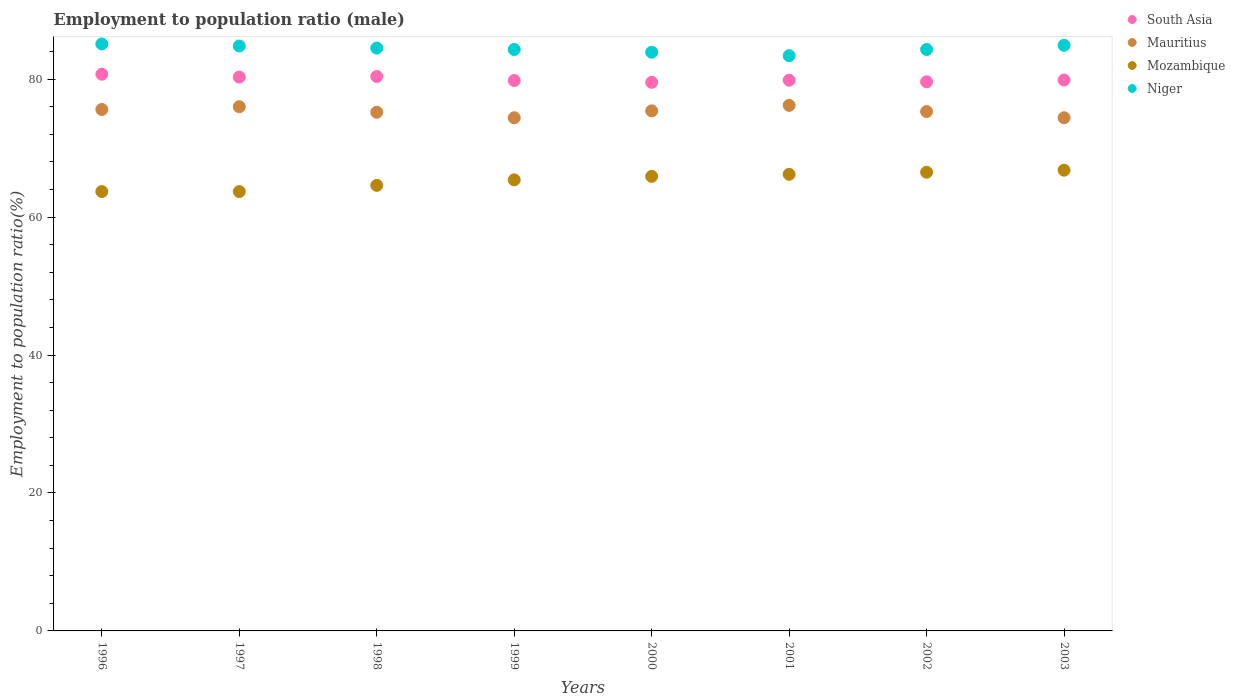Is the number of dotlines equal to the number of legend labels?
Offer a very short reply. Yes. What is the employment to population ratio in Niger in 2000?
Provide a short and direct response. 83.9. Across all years, what is the maximum employment to population ratio in Niger?
Ensure brevity in your answer.  85.1. Across all years, what is the minimum employment to population ratio in South Asia?
Keep it short and to the point. 79.53. In which year was the employment to population ratio in Niger maximum?
Your response must be concise. 1996. What is the total employment to population ratio in Mauritius in the graph?
Keep it short and to the point. 602.5. What is the difference between the employment to population ratio in Niger in 1997 and that in 2000?
Your answer should be very brief. 0.9. What is the difference between the employment to population ratio in Niger in 2002 and the employment to population ratio in South Asia in 1997?
Provide a short and direct response. 4. What is the average employment to population ratio in South Asia per year?
Offer a terse response. 80.01. In the year 2003, what is the difference between the employment to population ratio in South Asia and employment to population ratio in Mauritius?
Give a very brief answer. 5.47. In how many years, is the employment to population ratio in Mozambique greater than 4 %?
Provide a short and direct response. 8. What is the ratio of the employment to population ratio in Mauritius in 1998 to that in 2000?
Provide a short and direct response. 1. Is the employment to population ratio in Mozambique in 2000 less than that in 2002?
Provide a succinct answer. Yes. What is the difference between the highest and the second highest employment to population ratio in Mozambique?
Make the answer very short. 0.3. What is the difference between the highest and the lowest employment to population ratio in Mauritius?
Give a very brief answer. 1.8. In how many years, is the employment to population ratio in Mauritius greater than the average employment to population ratio in Mauritius taken over all years?
Give a very brief answer. 4. Is it the case that in every year, the sum of the employment to population ratio in Mozambique and employment to population ratio in Mauritius  is greater than the sum of employment to population ratio in Niger and employment to population ratio in South Asia?
Provide a short and direct response. No. Is the employment to population ratio in Mauritius strictly greater than the employment to population ratio in South Asia over the years?
Make the answer very short. No. Is the employment to population ratio in Mozambique strictly less than the employment to population ratio in Niger over the years?
Make the answer very short. Yes. How many dotlines are there?
Your answer should be compact. 4. What is the difference between two consecutive major ticks on the Y-axis?
Offer a very short reply. 20. Does the graph contain grids?
Make the answer very short. No. How are the legend labels stacked?
Your answer should be compact. Vertical. What is the title of the graph?
Offer a very short reply. Employment to population ratio (male). What is the label or title of the X-axis?
Provide a succinct answer. Years. What is the Employment to population ratio(%) of South Asia in 1996?
Provide a short and direct response. 80.71. What is the Employment to population ratio(%) in Mauritius in 1996?
Keep it short and to the point. 75.6. What is the Employment to population ratio(%) of Mozambique in 1996?
Offer a very short reply. 63.7. What is the Employment to population ratio(%) in Niger in 1996?
Make the answer very short. 85.1. What is the Employment to population ratio(%) of South Asia in 1997?
Provide a succinct answer. 80.3. What is the Employment to population ratio(%) of Mauritius in 1997?
Make the answer very short. 76. What is the Employment to population ratio(%) in Mozambique in 1997?
Provide a succinct answer. 63.7. What is the Employment to population ratio(%) of Niger in 1997?
Keep it short and to the point. 84.8. What is the Employment to population ratio(%) of South Asia in 1998?
Offer a very short reply. 80.38. What is the Employment to population ratio(%) in Mauritius in 1998?
Your response must be concise. 75.2. What is the Employment to population ratio(%) of Mozambique in 1998?
Your response must be concise. 64.6. What is the Employment to population ratio(%) of Niger in 1998?
Provide a short and direct response. 84.5. What is the Employment to population ratio(%) in South Asia in 1999?
Your response must be concise. 79.8. What is the Employment to population ratio(%) in Mauritius in 1999?
Offer a terse response. 74.4. What is the Employment to population ratio(%) in Mozambique in 1999?
Offer a terse response. 65.4. What is the Employment to population ratio(%) in Niger in 1999?
Provide a short and direct response. 84.3. What is the Employment to population ratio(%) of South Asia in 2000?
Provide a short and direct response. 79.53. What is the Employment to population ratio(%) of Mauritius in 2000?
Your response must be concise. 75.4. What is the Employment to population ratio(%) of Mozambique in 2000?
Provide a short and direct response. 65.9. What is the Employment to population ratio(%) of Niger in 2000?
Offer a very short reply. 83.9. What is the Employment to population ratio(%) of South Asia in 2001?
Give a very brief answer. 79.84. What is the Employment to population ratio(%) of Mauritius in 2001?
Your response must be concise. 76.2. What is the Employment to population ratio(%) in Mozambique in 2001?
Offer a very short reply. 66.2. What is the Employment to population ratio(%) of Niger in 2001?
Offer a very short reply. 83.4. What is the Employment to population ratio(%) in South Asia in 2002?
Make the answer very short. 79.62. What is the Employment to population ratio(%) in Mauritius in 2002?
Make the answer very short. 75.3. What is the Employment to population ratio(%) in Mozambique in 2002?
Your answer should be compact. 66.5. What is the Employment to population ratio(%) in Niger in 2002?
Offer a terse response. 84.3. What is the Employment to population ratio(%) in South Asia in 2003?
Offer a terse response. 79.87. What is the Employment to population ratio(%) of Mauritius in 2003?
Make the answer very short. 74.4. What is the Employment to population ratio(%) in Mozambique in 2003?
Offer a very short reply. 66.8. What is the Employment to population ratio(%) of Niger in 2003?
Your response must be concise. 84.9. Across all years, what is the maximum Employment to population ratio(%) of South Asia?
Provide a short and direct response. 80.71. Across all years, what is the maximum Employment to population ratio(%) in Mauritius?
Your answer should be very brief. 76.2. Across all years, what is the maximum Employment to population ratio(%) in Mozambique?
Keep it short and to the point. 66.8. Across all years, what is the maximum Employment to population ratio(%) of Niger?
Offer a very short reply. 85.1. Across all years, what is the minimum Employment to population ratio(%) of South Asia?
Ensure brevity in your answer.  79.53. Across all years, what is the minimum Employment to population ratio(%) in Mauritius?
Your answer should be compact. 74.4. Across all years, what is the minimum Employment to population ratio(%) in Mozambique?
Provide a short and direct response. 63.7. Across all years, what is the minimum Employment to population ratio(%) in Niger?
Your answer should be compact. 83.4. What is the total Employment to population ratio(%) in South Asia in the graph?
Keep it short and to the point. 640.06. What is the total Employment to population ratio(%) of Mauritius in the graph?
Give a very brief answer. 602.5. What is the total Employment to population ratio(%) of Mozambique in the graph?
Provide a succinct answer. 522.8. What is the total Employment to population ratio(%) of Niger in the graph?
Provide a succinct answer. 675.2. What is the difference between the Employment to population ratio(%) in South Asia in 1996 and that in 1997?
Ensure brevity in your answer.  0.42. What is the difference between the Employment to population ratio(%) of Mauritius in 1996 and that in 1997?
Keep it short and to the point. -0.4. What is the difference between the Employment to population ratio(%) in Mozambique in 1996 and that in 1997?
Your response must be concise. 0. What is the difference between the Employment to population ratio(%) in South Asia in 1996 and that in 1998?
Your answer should be very brief. 0.34. What is the difference between the Employment to population ratio(%) of Mozambique in 1996 and that in 1998?
Your answer should be very brief. -0.9. What is the difference between the Employment to population ratio(%) of South Asia in 1996 and that in 1999?
Give a very brief answer. 0.91. What is the difference between the Employment to population ratio(%) in Mauritius in 1996 and that in 1999?
Give a very brief answer. 1.2. What is the difference between the Employment to population ratio(%) in South Asia in 1996 and that in 2000?
Your answer should be compact. 1.18. What is the difference between the Employment to population ratio(%) of South Asia in 1996 and that in 2001?
Provide a succinct answer. 0.87. What is the difference between the Employment to population ratio(%) of Mauritius in 1996 and that in 2001?
Offer a terse response. -0.6. What is the difference between the Employment to population ratio(%) in Mozambique in 1996 and that in 2001?
Offer a very short reply. -2.5. What is the difference between the Employment to population ratio(%) in Niger in 1996 and that in 2001?
Offer a terse response. 1.7. What is the difference between the Employment to population ratio(%) of South Asia in 1996 and that in 2002?
Give a very brief answer. 1.1. What is the difference between the Employment to population ratio(%) in Mauritius in 1996 and that in 2002?
Your response must be concise. 0.3. What is the difference between the Employment to population ratio(%) in Niger in 1996 and that in 2002?
Your answer should be very brief. 0.8. What is the difference between the Employment to population ratio(%) of South Asia in 1996 and that in 2003?
Make the answer very short. 0.85. What is the difference between the Employment to population ratio(%) in Mauritius in 1996 and that in 2003?
Your answer should be compact. 1.2. What is the difference between the Employment to population ratio(%) in South Asia in 1997 and that in 1998?
Keep it short and to the point. -0.08. What is the difference between the Employment to population ratio(%) in Mozambique in 1997 and that in 1998?
Make the answer very short. -0.9. What is the difference between the Employment to population ratio(%) of South Asia in 1997 and that in 1999?
Provide a succinct answer. 0.5. What is the difference between the Employment to population ratio(%) of Mozambique in 1997 and that in 1999?
Offer a very short reply. -1.7. What is the difference between the Employment to population ratio(%) of South Asia in 1997 and that in 2000?
Your response must be concise. 0.76. What is the difference between the Employment to population ratio(%) in Mozambique in 1997 and that in 2000?
Provide a succinct answer. -2.2. What is the difference between the Employment to population ratio(%) of South Asia in 1997 and that in 2001?
Provide a succinct answer. 0.46. What is the difference between the Employment to population ratio(%) of Mauritius in 1997 and that in 2001?
Give a very brief answer. -0.2. What is the difference between the Employment to population ratio(%) in Mozambique in 1997 and that in 2001?
Ensure brevity in your answer.  -2.5. What is the difference between the Employment to population ratio(%) in South Asia in 1997 and that in 2002?
Ensure brevity in your answer.  0.68. What is the difference between the Employment to population ratio(%) in Mauritius in 1997 and that in 2002?
Your response must be concise. 0.7. What is the difference between the Employment to population ratio(%) in South Asia in 1997 and that in 2003?
Offer a terse response. 0.43. What is the difference between the Employment to population ratio(%) in Mauritius in 1997 and that in 2003?
Keep it short and to the point. 1.6. What is the difference between the Employment to population ratio(%) of Mozambique in 1997 and that in 2003?
Ensure brevity in your answer.  -3.1. What is the difference between the Employment to population ratio(%) of Niger in 1997 and that in 2003?
Offer a very short reply. -0.1. What is the difference between the Employment to population ratio(%) in South Asia in 1998 and that in 1999?
Give a very brief answer. 0.58. What is the difference between the Employment to population ratio(%) in Mauritius in 1998 and that in 1999?
Offer a very short reply. 0.8. What is the difference between the Employment to population ratio(%) in Niger in 1998 and that in 1999?
Provide a short and direct response. 0.2. What is the difference between the Employment to population ratio(%) in South Asia in 1998 and that in 2000?
Give a very brief answer. 0.85. What is the difference between the Employment to population ratio(%) of Mauritius in 1998 and that in 2000?
Provide a succinct answer. -0.2. What is the difference between the Employment to population ratio(%) of Niger in 1998 and that in 2000?
Your answer should be compact. 0.6. What is the difference between the Employment to population ratio(%) of South Asia in 1998 and that in 2001?
Offer a terse response. 0.54. What is the difference between the Employment to population ratio(%) in Mauritius in 1998 and that in 2001?
Your answer should be compact. -1. What is the difference between the Employment to population ratio(%) of Mozambique in 1998 and that in 2001?
Offer a terse response. -1.6. What is the difference between the Employment to population ratio(%) in Niger in 1998 and that in 2001?
Your response must be concise. 1.1. What is the difference between the Employment to population ratio(%) in South Asia in 1998 and that in 2002?
Offer a terse response. 0.76. What is the difference between the Employment to population ratio(%) of Mauritius in 1998 and that in 2002?
Offer a very short reply. -0.1. What is the difference between the Employment to population ratio(%) of Niger in 1998 and that in 2002?
Offer a terse response. 0.2. What is the difference between the Employment to population ratio(%) of South Asia in 1998 and that in 2003?
Ensure brevity in your answer.  0.51. What is the difference between the Employment to population ratio(%) of Niger in 1998 and that in 2003?
Keep it short and to the point. -0.4. What is the difference between the Employment to population ratio(%) in South Asia in 1999 and that in 2000?
Offer a terse response. 0.27. What is the difference between the Employment to population ratio(%) in Mozambique in 1999 and that in 2000?
Keep it short and to the point. -0.5. What is the difference between the Employment to population ratio(%) in Niger in 1999 and that in 2000?
Offer a terse response. 0.4. What is the difference between the Employment to population ratio(%) of South Asia in 1999 and that in 2001?
Your answer should be compact. -0.04. What is the difference between the Employment to population ratio(%) in Mauritius in 1999 and that in 2001?
Offer a terse response. -1.8. What is the difference between the Employment to population ratio(%) in South Asia in 1999 and that in 2002?
Your response must be concise. 0.19. What is the difference between the Employment to population ratio(%) in Mauritius in 1999 and that in 2002?
Your response must be concise. -0.9. What is the difference between the Employment to population ratio(%) of Niger in 1999 and that in 2002?
Your response must be concise. 0. What is the difference between the Employment to population ratio(%) in South Asia in 1999 and that in 2003?
Your response must be concise. -0.07. What is the difference between the Employment to population ratio(%) in Niger in 1999 and that in 2003?
Provide a short and direct response. -0.6. What is the difference between the Employment to population ratio(%) of South Asia in 2000 and that in 2001?
Your answer should be very brief. -0.31. What is the difference between the Employment to population ratio(%) of Niger in 2000 and that in 2001?
Provide a short and direct response. 0.5. What is the difference between the Employment to population ratio(%) of South Asia in 2000 and that in 2002?
Your answer should be very brief. -0.08. What is the difference between the Employment to population ratio(%) in Mauritius in 2000 and that in 2002?
Offer a terse response. 0.1. What is the difference between the Employment to population ratio(%) in Mozambique in 2000 and that in 2002?
Offer a very short reply. -0.6. What is the difference between the Employment to population ratio(%) in South Asia in 2000 and that in 2003?
Provide a short and direct response. -0.34. What is the difference between the Employment to population ratio(%) in Mozambique in 2000 and that in 2003?
Your response must be concise. -0.9. What is the difference between the Employment to population ratio(%) in Niger in 2000 and that in 2003?
Provide a short and direct response. -1. What is the difference between the Employment to population ratio(%) of South Asia in 2001 and that in 2002?
Your response must be concise. 0.23. What is the difference between the Employment to population ratio(%) in Mozambique in 2001 and that in 2002?
Offer a very short reply. -0.3. What is the difference between the Employment to population ratio(%) in South Asia in 2001 and that in 2003?
Offer a terse response. -0.03. What is the difference between the Employment to population ratio(%) in Mauritius in 2001 and that in 2003?
Make the answer very short. 1.8. What is the difference between the Employment to population ratio(%) of Niger in 2001 and that in 2003?
Offer a very short reply. -1.5. What is the difference between the Employment to population ratio(%) in South Asia in 2002 and that in 2003?
Your answer should be compact. -0.25. What is the difference between the Employment to population ratio(%) of Mauritius in 2002 and that in 2003?
Offer a terse response. 0.9. What is the difference between the Employment to population ratio(%) in South Asia in 1996 and the Employment to population ratio(%) in Mauritius in 1997?
Keep it short and to the point. 4.71. What is the difference between the Employment to population ratio(%) of South Asia in 1996 and the Employment to population ratio(%) of Mozambique in 1997?
Make the answer very short. 17.01. What is the difference between the Employment to population ratio(%) in South Asia in 1996 and the Employment to population ratio(%) in Niger in 1997?
Provide a succinct answer. -4.09. What is the difference between the Employment to population ratio(%) of Mauritius in 1996 and the Employment to population ratio(%) of Mozambique in 1997?
Your response must be concise. 11.9. What is the difference between the Employment to population ratio(%) of Mozambique in 1996 and the Employment to population ratio(%) of Niger in 1997?
Offer a very short reply. -21.1. What is the difference between the Employment to population ratio(%) in South Asia in 1996 and the Employment to population ratio(%) in Mauritius in 1998?
Offer a terse response. 5.51. What is the difference between the Employment to population ratio(%) of South Asia in 1996 and the Employment to population ratio(%) of Mozambique in 1998?
Your answer should be very brief. 16.11. What is the difference between the Employment to population ratio(%) in South Asia in 1996 and the Employment to population ratio(%) in Niger in 1998?
Ensure brevity in your answer.  -3.79. What is the difference between the Employment to population ratio(%) in Mauritius in 1996 and the Employment to population ratio(%) in Niger in 1998?
Your answer should be compact. -8.9. What is the difference between the Employment to population ratio(%) in Mozambique in 1996 and the Employment to population ratio(%) in Niger in 1998?
Provide a short and direct response. -20.8. What is the difference between the Employment to population ratio(%) of South Asia in 1996 and the Employment to population ratio(%) of Mauritius in 1999?
Your response must be concise. 6.31. What is the difference between the Employment to population ratio(%) in South Asia in 1996 and the Employment to population ratio(%) in Mozambique in 1999?
Keep it short and to the point. 15.31. What is the difference between the Employment to population ratio(%) of South Asia in 1996 and the Employment to population ratio(%) of Niger in 1999?
Make the answer very short. -3.59. What is the difference between the Employment to population ratio(%) in Mozambique in 1996 and the Employment to population ratio(%) in Niger in 1999?
Your answer should be compact. -20.6. What is the difference between the Employment to population ratio(%) in South Asia in 1996 and the Employment to population ratio(%) in Mauritius in 2000?
Your response must be concise. 5.31. What is the difference between the Employment to population ratio(%) of South Asia in 1996 and the Employment to population ratio(%) of Mozambique in 2000?
Your answer should be very brief. 14.81. What is the difference between the Employment to population ratio(%) in South Asia in 1996 and the Employment to population ratio(%) in Niger in 2000?
Provide a short and direct response. -3.19. What is the difference between the Employment to population ratio(%) of Mauritius in 1996 and the Employment to population ratio(%) of Mozambique in 2000?
Offer a very short reply. 9.7. What is the difference between the Employment to population ratio(%) of Mauritius in 1996 and the Employment to population ratio(%) of Niger in 2000?
Provide a succinct answer. -8.3. What is the difference between the Employment to population ratio(%) of Mozambique in 1996 and the Employment to population ratio(%) of Niger in 2000?
Your answer should be very brief. -20.2. What is the difference between the Employment to population ratio(%) in South Asia in 1996 and the Employment to population ratio(%) in Mauritius in 2001?
Keep it short and to the point. 4.51. What is the difference between the Employment to population ratio(%) in South Asia in 1996 and the Employment to population ratio(%) in Mozambique in 2001?
Offer a terse response. 14.51. What is the difference between the Employment to population ratio(%) in South Asia in 1996 and the Employment to population ratio(%) in Niger in 2001?
Your response must be concise. -2.69. What is the difference between the Employment to population ratio(%) of Mauritius in 1996 and the Employment to population ratio(%) of Mozambique in 2001?
Your answer should be compact. 9.4. What is the difference between the Employment to population ratio(%) of Mauritius in 1996 and the Employment to population ratio(%) of Niger in 2001?
Keep it short and to the point. -7.8. What is the difference between the Employment to population ratio(%) of Mozambique in 1996 and the Employment to population ratio(%) of Niger in 2001?
Offer a terse response. -19.7. What is the difference between the Employment to population ratio(%) in South Asia in 1996 and the Employment to population ratio(%) in Mauritius in 2002?
Provide a succinct answer. 5.41. What is the difference between the Employment to population ratio(%) of South Asia in 1996 and the Employment to population ratio(%) of Mozambique in 2002?
Provide a succinct answer. 14.21. What is the difference between the Employment to population ratio(%) in South Asia in 1996 and the Employment to population ratio(%) in Niger in 2002?
Make the answer very short. -3.59. What is the difference between the Employment to population ratio(%) of Mozambique in 1996 and the Employment to population ratio(%) of Niger in 2002?
Make the answer very short. -20.6. What is the difference between the Employment to population ratio(%) of South Asia in 1996 and the Employment to population ratio(%) of Mauritius in 2003?
Your answer should be compact. 6.31. What is the difference between the Employment to population ratio(%) in South Asia in 1996 and the Employment to population ratio(%) in Mozambique in 2003?
Your answer should be very brief. 13.91. What is the difference between the Employment to population ratio(%) of South Asia in 1996 and the Employment to population ratio(%) of Niger in 2003?
Provide a succinct answer. -4.19. What is the difference between the Employment to population ratio(%) of Mauritius in 1996 and the Employment to population ratio(%) of Mozambique in 2003?
Your answer should be very brief. 8.8. What is the difference between the Employment to population ratio(%) of Mauritius in 1996 and the Employment to population ratio(%) of Niger in 2003?
Your answer should be very brief. -9.3. What is the difference between the Employment to population ratio(%) of Mozambique in 1996 and the Employment to population ratio(%) of Niger in 2003?
Your response must be concise. -21.2. What is the difference between the Employment to population ratio(%) of South Asia in 1997 and the Employment to population ratio(%) of Mauritius in 1998?
Your answer should be very brief. 5.1. What is the difference between the Employment to population ratio(%) of South Asia in 1997 and the Employment to population ratio(%) of Mozambique in 1998?
Make the answer very short. 15.7. What is the difference between the Employment to population ratio(%) of South Asia in 1997 and the Employment to population ratio(%) of Niger in 1998?
Give a very brief answer. -4.2. What is the difference between the Employment to population ratio(%) of Mauritius in 1997 and the Employment to population ratio(%) of Mozambique in 1998?
Offer a terse response. 11.4. What is the difference between the Employment to population ratio(%) of Mozambique in 1997 and the Employment to population ratio(%) of Niger in 1998?
Make the answer very short. -20.8. What is the difference between the Employment to population ratio(%) of South Asia in 1997 and the Employment to population ratio(%) of Mauritius in 1999?
Offer a very short reply. 5.9. What is the difference between the Employment to population ratio(%) in South Asia in 1997 and the Employment to population ratio(%) in Mozambique in 1999?
Your answer should be compact. 14.9. What is the difference between the Employment to population ratio(%) in South Asia in 1997 and the Employment to population ratio(%) in Niger in 1999?
Make the answer very short. -4. What is the difference between the Employment to population ratio(%) in Mauritius in 1997 and the Employment to population ratio(%) in Niger in 1999?
Provide a short and direct response. -8.3. What is the difference between the Employment to population ratio(%) in Mozambique in 1997 and the Employment to population ratio(%) in Niger in 1999?
Provide a short and direct response. -20.6. What is the difference between the Employment to population ratio(%) of South Asia in 1997 and the Employment to population ratio(%) of Mauritius in 2000?
Offer a terse response. 4.9. What is the difference between the Employment to population ratio(%) of South Asia in 1997 and the Employment to population ratio(%) of Mozambique in 2000?
Offer a very short reply. 14.4. What is the difference between the Employment to population ratio(%) of South Asia in 1997 and the Employment to population ratio(%) of Niger in 2000?
Your response must be concise. -3.6. What is the difference between the Employment to population ratio(%) in Mauritius in 1997 and the Employment to population ratio(%) in Mozambique in 2000?
Offer a very short reply. 10.1. What is the difference between the Employment to population ratio(%) of Mauritius in 1997 and the Employment to population ratio(%) of Niger in 2000?
Your answer should be compact. -7.9. What is the difference between the Employment to population ratio(%) in Mozambique in 1997 and the Employment to population ratio(%) in Niger in 2000?
Provide a succinct answer. -20.2. What is the difference between the Employment to population ratio(%) in South Asia in 1997 and the Employment to population ratio(%) in Mauritius in 2001?
Ensure brevity in your answer.  4.1. What is the difference between the Employment to population ratio(%) of South Asia in 1997 and the Employment to population ratio(%) of Mozambique in 2001?
Make the answer very short. 14.1. What is the difference between the Employment to population ratio(%) of South Asia in 1997 and the Employment to population ratio(%) of Niger in 2001?
Provide a succinct answer. -3.1. What is the difference between the Employment to population ratio(%) of Mauritius in 1997 and the Employment to population ratio(%) of Niger in 2001?
Your answer should be compact. -7.4. What is the difference between the Employment to population ratio(%) in Mozambique in 1997 and the Employment to population ratio(%) in Niger in 2001?
Ensure brevity in your answer.  -19.7. What is the difference between the Employment to population ratio(%) of South Asia in 1997 and the Employment to population ratio(%) of Mauritius in 2002?
Keep it short and to the point. 5. What is the difference between the Employment to population ratio(%) in South Asia in 1997 and the Employment to population ratio(%) in Mozambique in 2002?
Offer a very short reply. 13.8. What is the difference between the Employment to population ratio(%) of South Asia in 1997 and the Employment to population ratio(%) of Niger in 2002?
Provide a short and direct response. -4. What is the difference between the Employment to population ratio(%) in Mozambique in 1997 and the Employment to population ratio(%) in Niger in 2002?
Offer a very short reply. -20.6. What is the difference between the Employment to population ratio(%) in South Asia in 1997 and the Employment to population ratio(%) in Mauritius in 2003?
Your answer should be very brief. 5.9. What is the difference between the Employment to population ratio(%) in South Asia in 1997 and the Employment to population ratio(%) in Mozambique in 2003?
Ensure brevity in your answer.  13.5. What is the difference between the Employment to population ratio(%) in South Asia in 1997 and the Employment to population ratio(%) in Niger in 2003?
Give a very brief answer. -4.6. What is the difference between the Employment to population ratio(%) of Mauritius in 1997 and the Employment to population ratio(%) of Mozambique in 2003?
Provide a succinct answer. 9.2. What is the difference between the Employment to population ratio(%) of Mozambique in 1997 and the Employment to population ratio(%) of Niger in 2003?
Keep it short and to the point. -21.2. What is the difference between the Employment to population ratio(%) of South Asia in 1998 and the Employment to population ratio(%) of Mauritius in 1999?
Your answer should be very brief. 5.98. What is the difference between the Employment to population ratio(%) of South Asia in 1998 and the Employment to population ratio(%) of Mozambique in 1999?
Provide a succinct answer. 14.98. What is the difference between the Employment to population ratio(%) of South Asia in 1998 and the Employment to population ratio(%) of Niger in 1999?
Ensure brevity in your answer.  -3.92. What is the difference between the Employment to population ratio(%) of Mauritius in 1998 and the Employment to population ratio(%) of Mozambique in 1999?
Ensure brevity in your answer.  9.8. What is the difference between the Employment to population ratio(%) in Mauritius in 1998 and the Employment to population ratio(%) in Niger in 1999?
Provide a short and direct response. -9.1. What is the difference between the Employment to population ratio(%) in Mozambique in 1998 and the Employment to population ratio(%) in Niger in 1999?
Your answer should be very brief. -19.7. What is the difference between the Employment to population ratio(%) in South Asia in 1998 and the Employment to population ratio(%) in Mauritius in 2000?
Your answer should be very brief. 4.98. What is the difference between the Employment to population ratio(%) of South Asia in 1998 and the Employment to population ratio(%) of Mozambique in 2000?
Offer a very short reply. 14.48. What is the difference between the Employment to population ratio(%) of South Asia in 1998 and the Employment to population ratio(%) of Niger in 2000?
Provide a succinct answer. -3.52. What is the difference between the Employment to population ratio(%) of Mauritius in 1998 and the Employment to population ratio(%) of Mozambique in 2000?
Provide a succinct answer. 9.3. What is the difference between the Employment to population ratio(%) of Mozambique in 1998 and the Employment to population ratio(%) of Niger in 2000?
Offer a very short reply. -19.3. What is the difference between the Employment to population ratio(%) in South Asia in 1998 and the Employment to population ratio(%) in Mauritius in 2001?
Provide a succinct answer. 4.18. What is the difference between the Employment to population ratio(%) in South Asia in 1998 and the Employment to population ratio(%) in Mozambique in 2001?
Your response must be concise. 14.18. What is the difference between the Employment to population ratio(%) in South Asia in 1998 and the Employment to population ratio(%) in Niger in 2001?
Give a very brief answer. -3.02. What is the difference between the Employment to population ratio(%) in Mauritius in 1998 and the Employment to population ratio(%) in Mozambique in 2001?
Offer a very short reply. 9. What is the difference between the Employment to population ratio(%) of Mauritius in 1998 and the Employment to population ratio(%) of Niger in 2001?
Keep it short and to the point. -8.2. What is the difference between the Employment to population ratio(%) of Mozambique in 1998 and the Employment to population ratio(%) of Niger in 2001?
Provide a succinct answer. -18.8. What is the difference between the Employment to population ratio(%) of South Asia in 1998 and the Employment to population ratio(%) of Mauritius in 2002?
Your answer should be very brief. 5.08. What is the difference between the Employment to population ratio(%) of South Asia in 1998 and the Employment to population ratio(%) of Mozambique in 2002?
Provide a succinct answer. 13.88. What is the difference between the Employment to population ratio(%) in South Asia in 1998 and the Employment to population ratio(%) in Niger in 2002?
Keep it short and to the point. -3.92. What is the difference between the Employment to population ratio(%) in Mauritius in 1998 and the Employment to population ratio(%) in Mozambique in 2002?
Offer a terse response. 8.7. What is the difference between the Employment to population ratio(%) in Mauritius in 1998 and the Employment to population ratio(%) in Niger in 2002?
Provide a succinct answer. -9.1. What is the difference between the Employment to population ratio(%) in Mozambique in 1998 and the Employment to population ratio(%) in Niger in 2002?
Give a very brief answer. -19.7. What is the difference between the Employment to population ratio(%) of South Asia in 1998 and the Employment to population ratio(%) of Mauritius in 2003?
Make the answer very short. 5.98. What is the difference between the Employment to population ratio(%) of South Asia in 1998 and the Employment to population ratio(%) of Mozambique in 2003?
Keep it short and to the point. 13.58. What is the difference between the Employment to population ratio(%) in South Asia in 1998 and the Employment to population ratio(%) in Niger in 2003?
Offer a terse response. -4.52. What is the difference between the Employment to population ratio(%) of Mauritius in 1998 and the Employment to population ratio(%) of Mozambique in 2003?
Keep it short and to the point. 8.4. What is the difference between the Employment to population ratio(%) of Mauritius in 1998 and the Employment to population ratio(%) of Niger in 2003?
Offer a terse response. -9.7. What is the difference between the Employment to population ratio(%) of Mozambique in 1998 and the Employment to population ratio(%) of Niger in 2003?
Provide a succinct answer. -20.3. What is the difference between the Employment to population ratio(%) of South Asia in 1999 and the Employment to population ratio(%) of Mauritius in 2000?
Your response must be concise. 4.4. What is the difference between the Employment to population ratio(%) in South Asia in 1999 and the Employment to population ratio(%) in Mozambique in 2000?
Your answer should be compact. 13.9. What is the difference between the Employment to population ratio(%) in South Asia in 1999 and the Employment to population ratio(%) in Niger in 2000?
Keep it short and to the point. -4.1. What is the difference between the Employment to population ratio(%) of Mauritius in 1999 and the Employment to population ratio(%) of Niger in 2000?
Keep it short and to the point. -9.5. What is the difference between the Employment to population ratio(%) of Mozambique in 1999 and the Employment to population ratio(%) of Niger in 2000?
Your answer should be compact. -18.5. What is the difference between the Employment to population ratio(%) of South Asia in 1999 and the Employment to population ratio(%) of Mauritius in 2001?
Give a very brief answer. 3.6. What is the difference between the Employment to population ratio(%) in South Asia in 1999 and the Employment to population ratio(%) in Mozambique in 2001?
Give a very brief answer. 13.6. What is the difference between the Employment to population ratio(%) in South Asia in 1999 and the Employment to population ratio(%) in Niger in 2001?
Make the answer very short. -3.6. What is the difference between the Employment to population ratio(%) in Mauritius in 1999 and the Employment to population ratio(%) in Niger in 2001?
Make the answer very short. -9. What is the difference between the Employment to population ratio(%) of South Asia in 1999 and the Employment to population ratio(%) of Mauritius in 2002?
Provide a succinct answer. 4.5. What is the difference between the Employment to population ratio(%) in South Asia in 1999 and the Employment to population ratio(%) in Mozambique in 2002?
Offer a very short reply. 13.3. What is the difference between the Employment to population ratio(%) of South Asia in 1999 and the Employment to population ratio(%) of Niger in 2002?
Your response must be concise. -4.5. What is the difference between the Employment to population ratio(%) in Mauritius in 1999 and the Employment to population ratio(%) in Mozambique in 2002?
Make the answer very short. 7.9. What is the difference between the Employment to population ratio(%) in Mozambique in 1999 and the Employment to population ratio(%) in Niger in 2002?
Ensure brevity in your answer.  -18.9. What is the difference between the Employment to population ratio(%) in South Asia in 1999 and the Employment to population ratio(%) in Mauritius in 2003?
Provide a short and direct response. 5.4. What is the difference between the Employment to population ratio(%) in South Asia in 1999 and the Employment to population ratio(%) in Mozambique in 2003?
Keep it short and to the point. 13. What is the difference between the Employment to population ratio(%) of South Asia in 1999 and the Employment to population ratio(%) of Niger in 2003?
Provide a succinct answer. -5.1. What is the difference between the Employment to population ratio(%) in Mauritius in 1999 and the Employment to population ratio(%) in Niger in 2003?
Make the answer very short. -10.5. What is the difference between the Employment to population ratio(%) of Mozambique in 1999 and the Employment to population ratio(%) of Niger in 2003?
Your answer should be very brief. -19.5. What is the difference between the Employment to population ratio(%) in South Asia in 2000 and the Employment to population ratio(%) in Mauritius in 2001?
Provide a succinct answer. 3.33. What is the difference between the Employment to population ratio(%) of South Asia in 2000 and the Employment to population ratio(%) of Mozambique in 2001?
Your response must be concise. 13.33. What is the difference between the Employment to population ratio(%) of South Asia in 2000 and the Employment to population ratio(%) of Niger in 2001?
Offer a terse response. -3.87. What is the difference between the Employment to population ratio(%) of Mauritius in 2000 and the Employment to population ratio(%) of Mozambique in 2001?
Your answer should be compact. 9.2. What is the difference between the Employment to population ratio(%) of Mauritius in 2000 and the Employment to population ratio(%) of Niger in 2001?
Ensure brevity in your answer.  -8. What is the difference between the Employment to population ratio(%) in Mozambique in 2000 and the Employment to population ratio(%) in Niger in 2001?
Keep it short and to the point. -17.5. What is the difference between the Employment to population ratio(%) in South Asia in 2000 and the Employment to population ratio(%) in Mauritius in 2002?
Offer a very short reply. 4.23. What is the difference between the Employment to population ratio(%) of South Asia in 2000 and the Employment to population ratio(%) of Mozambique in 2002?
Ensure brevity in your answer.  13.03. What is the difference between the Employment to population ratio(%) of South Asia in 2000 and the Employment to population ratio(%) of Niger in 2002?
Give a very brief answer. -4.77. What is the difference between the Employment to population ratio(%) in Mozambique in 2000 and the Employment to population ratio(%) in Niger in 2002?
Provide a short and direct response. -18.4. What is the difference between the Employment to population ratio(%) of South Asia in 2000 and the Employment to population ratio(%) of Mauritius in 2003?
Give a very brief answer. 5.13. What is the difference between the Employment to population ratio(%) of South Asia in 2000 and the Employment to population ratio(%) of Mozambique in 2003?
Provide a succinct answer. 12.73. What is the difference between the Employment to population ratio(%) of South Asia in 2000 and the Employment to population ratio(%) of Niger in 2003?
Offer a terse response. -5.37. What is the difference between the Employment to population ratio(%) in Mauritius in 2000 and the Employment to population ratio(%) in Mozambique in 2003?
Offer a very short reply. 8.6. What is the difference between the Employment to population ratio(%) of Mauritius in 2000 and the Employment to population ratio(%) of Niger in 2003?
Give a very brief answer. -9.5. What is the difference between the Employment to population ratio(%) in Mozambique in 2000 and the Employment to population ratio(%) in Niger in 2003?
Provide a succinct answer. -19. What is the difference between the Employment to population ratio(%) in South Asia in 2001 and the Employment to population ratio(%) in Mauritius in 2002?
Your response must be concise. 4.54. What is the difference between the Employment to population ratio(%) in South Asia in 2001 and the Employment to population ratio(%) in Mozambique in 2002?
Offer a terse response. 13.34. What is the difference between the Employment to population ratio(%) in South Asia in 2001 and the Employment to population ratio(%) in Niger in 2002?
Provide a succinct answer. -4.46. What is the difference between the Employment to population ratio(%) of Mozambique in 2001 and the Employment to population ratio(%) of Niger in 2002?
Provide a short and direct response. -18.1. What is the difference between the Employment to population ratio(%) of South Asia in 2001 and the Employment to population ratio(%) of Mauritius in 2003?
Your answer should be compact. 5.44. What is the difference between the Employment to population ratio(%) of South Asia in 2001 and the Employment to population ratio(%) of Mozambique in 2003?
Make the answer very short. 13.04. What is the difference between the Employment to population ratio(%) in South Asia in 2001 and the Employment to population ratio(%) in Niger in 2003?
Give a very brief answer. -5.06. What is the difference between the Employment to population ratio(%) of Mauritius in 2001 and the Employment to population ratio(%) of Niger in 2003?
Your answer should be compact. -8.7. What is the difference between the Employment to population ratio(%) of Mozambique in 2001 and the Employment to population ratio(%) of Niger in 2003?
Ensure brevity in your answer.  -18.7. What is the difference between the Employment to population ratio(%) in South Asia in 2002 and the Employment to population ratio(%) in Mauritius in 2003?
Offer a terse response. 5.22. What is the difference between the Employment to population ratio(%) in South Asia in 2002 and the Employment to population ratio(%) in Mozambique in 2003?
Offer a very short reply. 12.82. What is the difference between the Employment to population ratio(%) of South Asia in 2002 and the Employment to population ratio(%) of Niger in 2003?
Provide a succinct answer. -5.28. What is the difference between the Employment to population ratio(%) in Mauritius in 2002 and the Employment to population ratio(%) in Mozambique in 2003?
Make the answer very short. 8.5. What is the difference between the Employment to population ratio(%) of Mozambique in 2002 and the Employment to population ratio(%) of Niger in 2003?
Your answer should be very brief. -18.4. What is the average Employment to population ratio(%) of South Asia per year?
Keep it short and to the point. 80.01. What is the average Employment to population ratio(%) in Mauritius per year?
Your response must be concise. 75.31. What is the average Employment to population ratio(%) in Mozambique per year?
Your answer should be compact. 65.35. What is the average Employment to population ratio(%) in Niger per year?
Offer a very short reply. 84.4. In the year 1996, what is the difference between the Employment to population ratio(%) of South Asia and Employment to population ratio(%) of Mauritius?
Keep it short and to the point. 5.11. In the year 1996, what is the difference between the Employment to population ratio(%) in South Asia and Employment to population ratio(%) in Mozambique?
Your answer should be very brief. 17.01. In the year 1996, what is the difference between the Employment to population ratio(%) of South Asia and Employment to population ratio(%) of Niger?
Give a very brief answer. -4.39. In the year 1996, what is the difference between the Employment to population ratio(%) of Mozambique and Employment to population ratio(%) of Niger?
Keep it short and to the point. -21.4. In the year 1997, what is the difference between the Employment to population ratio(%) in South Asia and Employment to population ratio(%) in Mauritius?
Offer a very short reply. 4.3. In the year 1997, what is the difference between the Employment to population ratio(%) in South Asia and Employment to population ratio(%) in Mozambique?
Keep it short and to the point. 16.6. In the year 1997, what is the difference between the Employment to population ratio(%) of South Asia and Employment to population ratio(%) of Niger?
Ensure brevity in your answer.  -4.5. In the year 1997, what is the difference between the Employment to population ratio(%) of Mauritius and Employment to population ratio(%) of Mozambique?
Provide a succinct answer. 12.3. In the year 1997, what is the difference between the Employment to population ratio(%) of Mozambique and Employment to population ratio(%) of Niger?
Your answer should be very brief. -21.1. In the year 1998, what is the difference between the Employment to population ratio(%) in South Asia and Employment to population ratio(%) in Mauritius?
Offer a terse response. 5.18. In the year 1998, what is the difference between the Employment to population ratio(%) in South Asia and Employment to population ratio(%) in Mozambique?
Keep it short and to the point. 15.78. In the year 1998, what is the difference between the Employment to population ratio(%) in South Asia and Employment to population ratio(%) in Niger?
Give a very brief answer. -4.12. In the year 1998, what is the difference between the Employment to population ratio(%) of Mozambique and Employment to population ratio(%) of Niger?
Your answer should be compact. -19.9. In the year 1999, what is the difference between the Employment to population ratio(%) in South Asia and Employment to population ratio(%) in Mauritius?
Provide a short and direct response. 5.4. In the year 1999, what is the difference between the Employment to population ratio(%) in South Asia and Employment to population ratio(%) in Mozambique?
Offer a very short reply. 14.4. In the year 1999, what is the difference between the Employment to population ratio(%) of South Asia and Employment to population ratio(%) of Niger?
Ensure brevity in your answer.  -4.5. In the year 1999, what is the difference between the Employment to population ratio(%) in Mauritius and Employment to population ratio(%) in Mozambique?
Give a very brief answer. 9. In the year 1999, what is the difference between the Employment to population ratio(%) in Mozambique and Employment to population ratio(%) in Niger?
Offer a terse response. -18.9. In the year 2000, what is the difference between the Employment to population ratio(%) of South Asia and Employment to population ratio(%) of Mauritius?
Keep it short and to the point. 4.13. In the year 2000, what is the difference between the Employment to population ratio(%) of South Asia and Employment to population ratio(%) of Mozambique?
Make the answer very short. 13.63. In the year 2000, what is the difference between the Employment to population ratio(%) of South Asia and Employment to population ratio(%) of Niger?
Offer a terse response. -4.37. In the year 2000, what is the difference between the Employment to population ratio(%) in Mauritius and Employment to population ratio(%) in Mozambique?
Provide a succinct answer. 9.5. In the year 2001, what is the difference between the Employment to population ratio(%) of South Asia and Employment to population ratio(%) of Mauritius?
Offer a very short reply. 3.64. In the year 2001, what is the difference between the Employment to population ratio(%) of South Asia and Employment to population ratio(%) of Mozambique?
Offer a terse response. 13.64. In the year 2001, what is the difference between the Employment to population ratio(%) of South Asia and Employment to population ratio(%) of Niger?
Offer a terse response. -3.56. In the year 2001, what is the difference between the Employment to population ratio(%) in Mozambique and Employment to population ratio(%) in Niger?
Your answer should be compact. -17.2. In the year 2002, what is the difference between the Employment to population ratio(%) of South Asia and Employment to population ratio(%) of Mauritius?
Give a very brief answer. 4.32. In the year 2002, what is the difference between the Employment to population ratio(%) in South Asia and Employment to population ratio(%) in Mozambique?
Keep it short and to the point. 13.12. In the year 2002, what is the difference between the Employment to population ratio(%) of South Asia and Employment to population ratio(%) of Niger?
Keep it short and to the point. -4.68. In the year 2002, what is the difference between the Employment to population ratio(%) in Mauritius and Employment to population ratio(%) in Mozambique?
Give a very brief answer. 8.8. In the year 2002, what is the difference between the Employment to population ratio(%) of Mozambique and Employment to population ratio(%) of Niger?
Make the answer very short. -17.8. In the year 2003, what is the difference between the Employment to population ratio(%) in South Asia and Employment to population ratio(%) in Mauritius?
Offer a terse response. 5.47. In the year 2003, what is the difference between the Employment to population ratio(%) in South Asia and Employment to population ratio(%) in Mozambique?
Your answer should be compact. 13.07. In the year 2003, what is the difference between the Employment to population ratio(%) of South Asia and Employment to population ratio(%) of Niger?
Provide a short and direct response. -5.03. In the year 2003, what is the difference between the Employment to population ratio(%) of Mauritius and Employment to population ratio(%) of Niger?
Your response must be concise. -10.5. In the year 2003, what is the difference between the Employment to population ratio(%) of Mozambique and Employment to population ratio(%) of Niger?
Give a very brief answer. -18.1. What is the ratio of the Employment to population ratio(%) in South Asia in 1996 to that in 1997?
Offer a very short reply. 1.01. What is the ratio of the Employment to population ratio(%) in South Asia in 1996 to that in 1998?
Ensure brevity in your answer.  1. What is the ratio of the Employment to population ratio(%) in Mozambique in 1996 to that in 1998?
Your answer should be very brief. 0.99. What is the ratio of the Employment to population ratio(%) in Niger in 1996 to that in 1998?
Offer a very short reply. 1.01. What is the ratio of the Employment to population ratio(%) in South Asia in 1996 to that in 1999?
Your answer should be compact. 1.01. What is the ratio of the Employment to population ratio(%) of Mauritius in 1996 to that in 1999?
Your answer should be compact. 1.02. What is the ratio of the Employment to population ratio(%) of Niger in 1996 to that in 1999?
Make the answer very short. 1.01. What is the ratio of the Employment to population ratio(%) of South Asia in 1996 to that in 2000?
Keep it short and to the point. 1.01. What is the ratio of the Employment to population ratio(%) of Mozambique in 1996 to that in 2000?
Ensure brevity in your answer.  0.97. What is the ratio of the Employment to population ratio(%) of Niger in 1996 to that in 2000?
Your answer should be compact. 1.01. What is the ratio of the Employment to population ratio(%) of South Asia in 1996 to that in 2001?
Your response must be concise. 1.01. What is the ratio of the Employment to population ratio(%) of Mozambique in 1996 to that in 2001?
Provide a short and direct response. 0.96. What is the ratio of the Employment to population ratio(%) of Niger in 1996 to that in 2001?
Provide a succinct answer. 1.02. What is the ratio of the Employment to population ratio(%) in South Asia in 1996 to that in 2002?
Make the answer very short. 1.01. What is the ratio of the Employment to population ratio(%) in Mozambique in 1996 to that in 2002?
Provide a succinct answer. 0.96. What is the ratio of the Employment to population ratio(%) in Niger in 1996 to that in 2002?
Keep it short and to the point. 1.01. What is the ratio of the Employment to population ratio(%) of South Asia in 1996 to that in 2003?
Offer a terse response. 1.01. What is the ratio of the Employment to population ratio(%) of Mauritius in 1996 to that in 2003?
Your response must be concise. 1.02. What is the ratio of the Employment to population ratio(%) of Mozambique in 1996 to that in 2003?
Give a very brief answer. 0.95. What is the ratio of the Employment to population ratio(%) of Niger in 1996 to that in 2003?
Provide a short and direct response. 1. What is the ratio of the Employment to population ratio(%) in Mauritius in 1997 to that in 1998?
Give a very brief answer. 1.01. What is the ratio of the Employment to population ratio(%) of Mozambique in 1997 to that in 1998?
Make the answer very short. 0.99. What is the ratio of the Employment to population ratio(%) in Niger in 1997 to that in 1998?
Offer a very short reply. 1. What is the ratio of the Employment to population ratio(%) of Mauritius in 1997 to that in 1999?
Keep it short and to the point. 1.02. What is the ratio of the Employment to population ratio(%) of Niger in 1997 to that in 1999?
Your answer should be very brief. 1.01. What is the ratio of the Employment to population ratio(%) of South Asia in 1997 to that in 2000?
Keep it short and to the point. 1.01. What is the ratio of the Employment to population ratio(%) in Mozambique in 1997 to that in 2000?
Keep it short and to the point. 0.97. What is the ratio of the Employment to population ratio(%) in Niger in 1997 to that in 2000?
Keep it short and to the point. 1.01. What is the ratio of the Employment to population ratio(%) of South Asia in 1997 to that in 2001?
Offer a terse response. 1.01. What is the ratio of the Employment to population ratio(%) of Mozambique in 1997 to that in 2001?
Provide a short and direct response. 0.96. What is the ratio of the Employment to population ratio(%) of Niger in 1997 to that in 2001?
Keep it short and to the point. 1.02. What is the ratio of the Employment to population ratio(%) in South Asia in 1997 to that in 2002?
Your answer should be compact. 1.01. What is the ratio of the Employment to population ratio(%) in Mauritius in 1997 to that in 2002?
Make the answer very short. 1.01. What is the ratio of the Employment to population ratio(%) in Mozambique in 1997 to that in 2002?
Your response must be concise. 0.96. What is the ratio of the Employment to population ratio(%) of Niger in 1997 to that in 2002?
Offer a terse response. 1.01. What is the ratio of the Employment to population ratio(%) in South Asia in 1997 to that in 2003?
Keep it short and to the point. 1.01. What is the ratio of the Employment to population ratio(%) in Mauritius in 1997 to that in 2003?
Your response must be concise. 1.02. What is the ratio of the Employment to population ratio(%) in Mozambique in 1997 to that in 2003?
Provide a short and direct response. 0.95. What is the ratio of the Employment to population ratio(%) of Mauritius in 1998 to that in 1999?
Your answer should be compact. 1.01. What is the ratio of the Employment to population ratio(%) of Mozambique in 1998 to that in 1999?
Offer a terse response. 0.99. What is the ratio of the Employment to population ratio(%) of South Asia in 1998 to that in 2000?
Your response must be concise. 1.01. What is the ratio of the Employment to population ratio(%) in Mauritius in 1998 to that in 2000?
Offer a very short reply. 1. What is the ratio of the Employment to population ratio(%) in Mozambique in 1998 to that in 2000?
Provide a succinct answer. 0.98. What is the ratio of the Employment to population ratio(%) in Niger in 1998 to that in 2000?
Your answer should be compact. 1.01. What is the ratio of the Employment to population ratio(%) in South Asia in 1998 to that in 2001?
Your response must be concise. 1.01. What is the ratio of the Employment to population ratio(%) of Mauritius in 1998 to that in 2001?
Make the answer very short. 0.99. What is the ratio of the Employment to population ratio(%) of Mozambique in 1998 to that in 2001?
Your answer should be compact. 0.98. What is the ratio of the Employment to population ratio(%) in Niger in 1998 to that in 2001?
Give a very brief answer. 1.01. What is the ratio of the Employment to population ratio(%) in South Asia in 1998 to that in 2002?
Keep it short and to the point. 1.01. What is the ratio of the Employment to population ratio(%) of Mauritius in 1998 to that in 2002?
Offer a terse response. 1. What is the ratio of the Employment to population ratio(%) of Mozambique in 1998 to that in 2002?
Provide a short and direct response. 0.97. What is the ratio of the Employment to population ratio(%) of Niger in 1998 to that in 2002?
Give a very brief answer. 1. What is the ratio of the Employment to population ratio(%) in South Asia in 1998 to that in 2003?
Ensure brevity in your answer.  1.01. What is the ratio of the Employment to population ratio(%) of Mauritius in 1998 to that in 2003?
Your answer should be very brief. 1.01. What is the ratio of the Employment to population ratio(%) in Mozambique in 1998 to that in 2003?
Give a very brief answer. 0.97. What is the ratio of the Employment to population ratio(%) in Niger in 1998 to that in 2003?
Your response must be concise. 1. What is the ratio of the Employment to population ratio(%) of South Asia in 1999 to that in 2000?
Offer a terse response. 1. What is the ratio of the Employment to population ratio(%) of Mauritius in 1999 to that in 2000?
Ensure brevity in your answer.  0.99. What is the ratio of the Employment to population ratio(%) in Mozambique in 1999 to that in 2000?
Give a very brief answer. 0.99. What is the ratio of the Employment to population ratio(%) in South Asia in 1999 to that in 2001?
Offer a very short reply. 1. What is the ratio of the Employment to population ratio(%) of Mauritius in 1999 to that in 2001?
Keep it short and to the point. 0.98. What is the ratio of the Employment to population ratio(%) in Mozambique in 1999 to that in 2001?
Your answer should be compact. 0.99. What is the ratio of the Employment to population ratio(%) of Niger in 1999 to that in 2001?
Keep it short and to the point. 1.01. What is the ratio of the Employment to population ratio(%) in South Asia in 1999 to that in 2002?
Your answer should be compact. 1. What is the ratio of the Employment to population ratio(%) in Mozambique in 1999 to that in 2002?
Your answer should be very brief. 0.98. What is the ratio of the Employment to population ratio(%) of Mauritius in 1999 to that in 2003?
Offer a very short reply. 1. What is the ratio of the Employment to population ratio(%) in Mauritius in 2000 to that in 2001?
Provide a short and direct response. 0.99. What is the ratio of the Employment to population ratio(%) of Mozambique in 2000 to that in 2001?
Make the answer very short. 1. What is the ratio of the Employment to population ratio(%) in Niger in 2000 to that in 2001?
Ensure brevity in your answer.  1.01. What is the ratio of the Employment to population ratio(%) in Mauritius in 2000 to that in 2002?
Keep it short and to the point. 1. What is the ratio of the Employment to population ratio(%) of South Asia in 2000 to that in 2003?
Your response must be concise. 1. What is the ratio of the Employment to population ratio(%) in Mauritius in 2000 to that in 2003?
Offer a terse response. 1.01. What is the ratio of the Employment to population ratio(%) of Mozambique in 2000 to that in 2003?
Provide a short and direct response. 0.99. What is the ratio of the Employment to population ratio(%) in South Asia in 2001 to that in 2002?
Your answer should be very brief. 1. What is the ratio of the Employment to population ratio(%) in Mozambique in 2001 to that in 2002?
Your answer should be very brief. 1. What is the ratio of the Employment to population ratio(%) of Niger in 2001 to that in 2002?
Keep it short and to the point. 0.99. What is the ratio of the Employment to population ratio(%) of Mauritius in 2001 to that in 2003?
Provide a short and direct response. 1.02. What is the ratio of the Employment to population ratio(%) in Niger in 2001 to that in 2003?
Keep it short and to the point. 0.98. What is the ratio of the Employment to population ratio(%) of South Asia in 2002 to that in 2003?
Give a very brief answer. 1. What is the ratio of the Employment to population ratio(%) of Mauritius in 2002 to that in 2003?
Ensure brevity in your answer.  1.01. What is the difference between the highest and the second highest Employment to population ratio(%) of South Asia?
Give a very brief answer. 0.34. What is the difference between the highest and the second highest Employment to population ratio(%) in Mozambique?
Your response must be concise. 0.3. What is the difference between the highest and the second highest Employment to population ratio(%) of Niger?
Provide a short and direct response. 0.2. What is the difference between the highest and the lowest Employment to population ratio(%) in South Asia?
Ensure brevity in your answer.  1.18. What is the difference between the highest and the lowest Employment to population ratio(%) of Niger?
Your response must be concise. 1.7. 